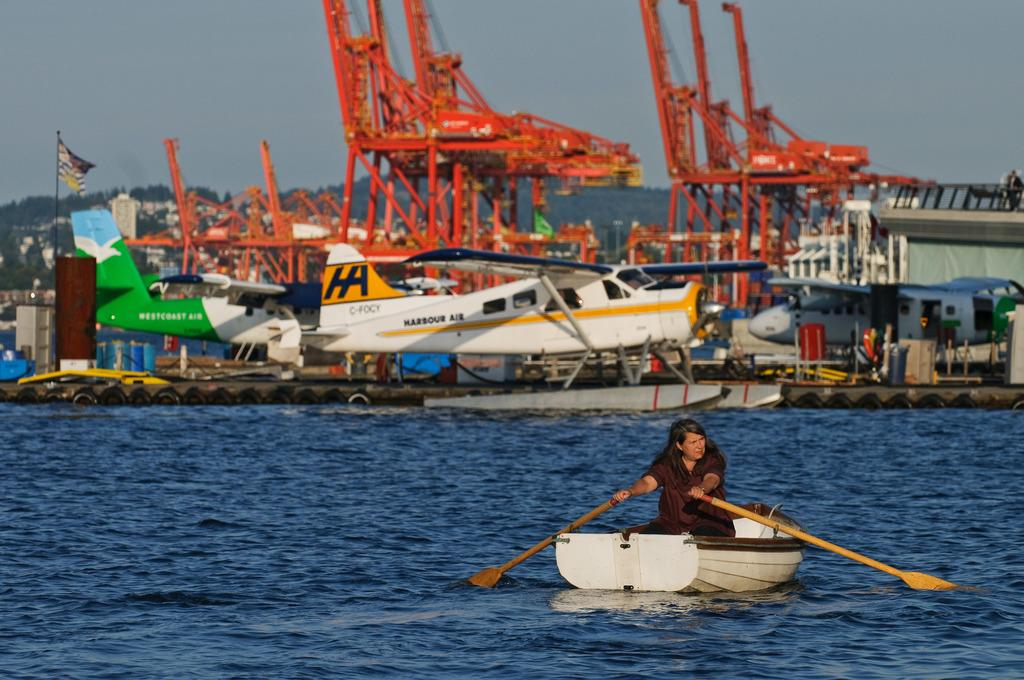What is the woman in the image doing? The woman is sailing a boat in the image. What can be seen in the background of the image? There are gliders, rods, the sky, and a flag in the background of the image. What is at the bottom of the image? There is water at the bottom of the image. What type of shade is being provided by the owl in the image? There is no owl present in the image, so no shade is being provided by an owl. 